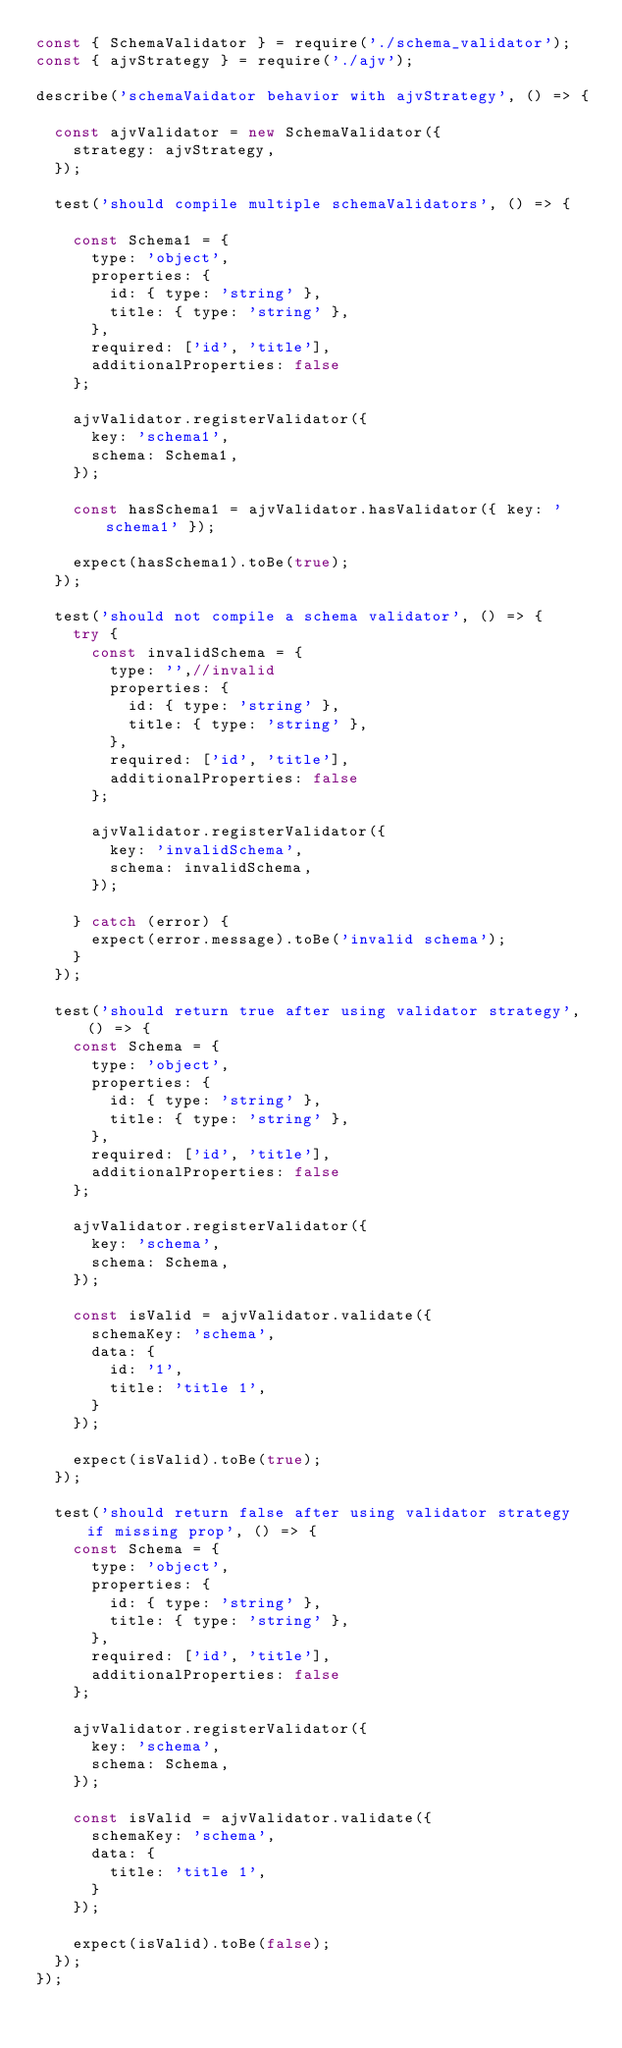<code> <loc_0><loc_0><loc_500><loc_500><_JavaScript_>const { SchemaValidator } = require('./schema_validator');
const { ajvStrategy } = require('./ajv');

describe('schemaVaidator behavior with ajvStrategy', () => {

  const ajvValidator = new SchemaValidator({
    strategy: ajvStrategy,
  });

  test('should compile multiple schemaValidators', () => {

    const Schema1 = {
      type: 'object',
      properties: {
        id: { type: 'string' },
        title: { type: 'string' },
      },
      required: ['id', 'title'],
      additionalProperties: false
    };

    ajvValidator.registerValidator({
      key: 'schema1',
      schema: Schema1,
    });

    const hasSchema1 = ajvValidator.hasValidator({ key: 'schema1' });

    expect(hasSchema1).toBe(true);
  });

  test('should not compile a schema validator', () => {
    try {
      const invalidSchema = {
        type: '',//invalid
        properties: {
          id: { type: 'string' },
          title: { type: 'string' },
        },
        required: ['id', 'title'],
        additionalProperties: false
      };

      ajvValidator.registerValidator({
        key: 'invalidSchema',
        schema: invalidSchema,
      });

    } catch (error) {
      expect(error.message).toBe('invalid schema');
    }
  });

  test('should return true after using validator strategy', () => {
    const Schema = {
      type: 'object',
      properties: {
        id: { type: 'string' },
        title: { type: 'string' },
      },
      required: ['id', 'title'],
      additionalProperties: false
    };

    ajvValidator.registerValidator({
      key: 'schema',
      schema: Schema,
    });

    const isValid = ajvValidator.validate({
      schemaKey: 'schema',
      data: {
        id: '1',
        title: 'title 1',
      }
    });

    expect(isValid).toBe(true);
  });

  test('should return false after using validator strategy if missing prop', () => {
    const Schema = {
      type: 'object',
      properties: {
        id: { type: 'string' },
        title: { type: 'string' },
      },
      required: ['id', 'title'],
      additionalProperties: false
    };

    ajvValidator.registerValidator({
      key: 'schema',
      schema: Schema,
    });

    const isValid = ajvValidator.validate({
      schemaKey: 'schema',
      data: {
        title: 'title 1',
      }
    });

    expect(isValid).toBe(false);
  });
});</code> 